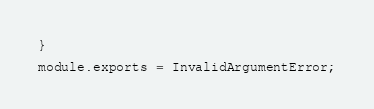<code> <loc_0><loc_0><loc_500><loc_500><_JavaScript_>
}

module.exports = InvalidArgumentError;
</code> 